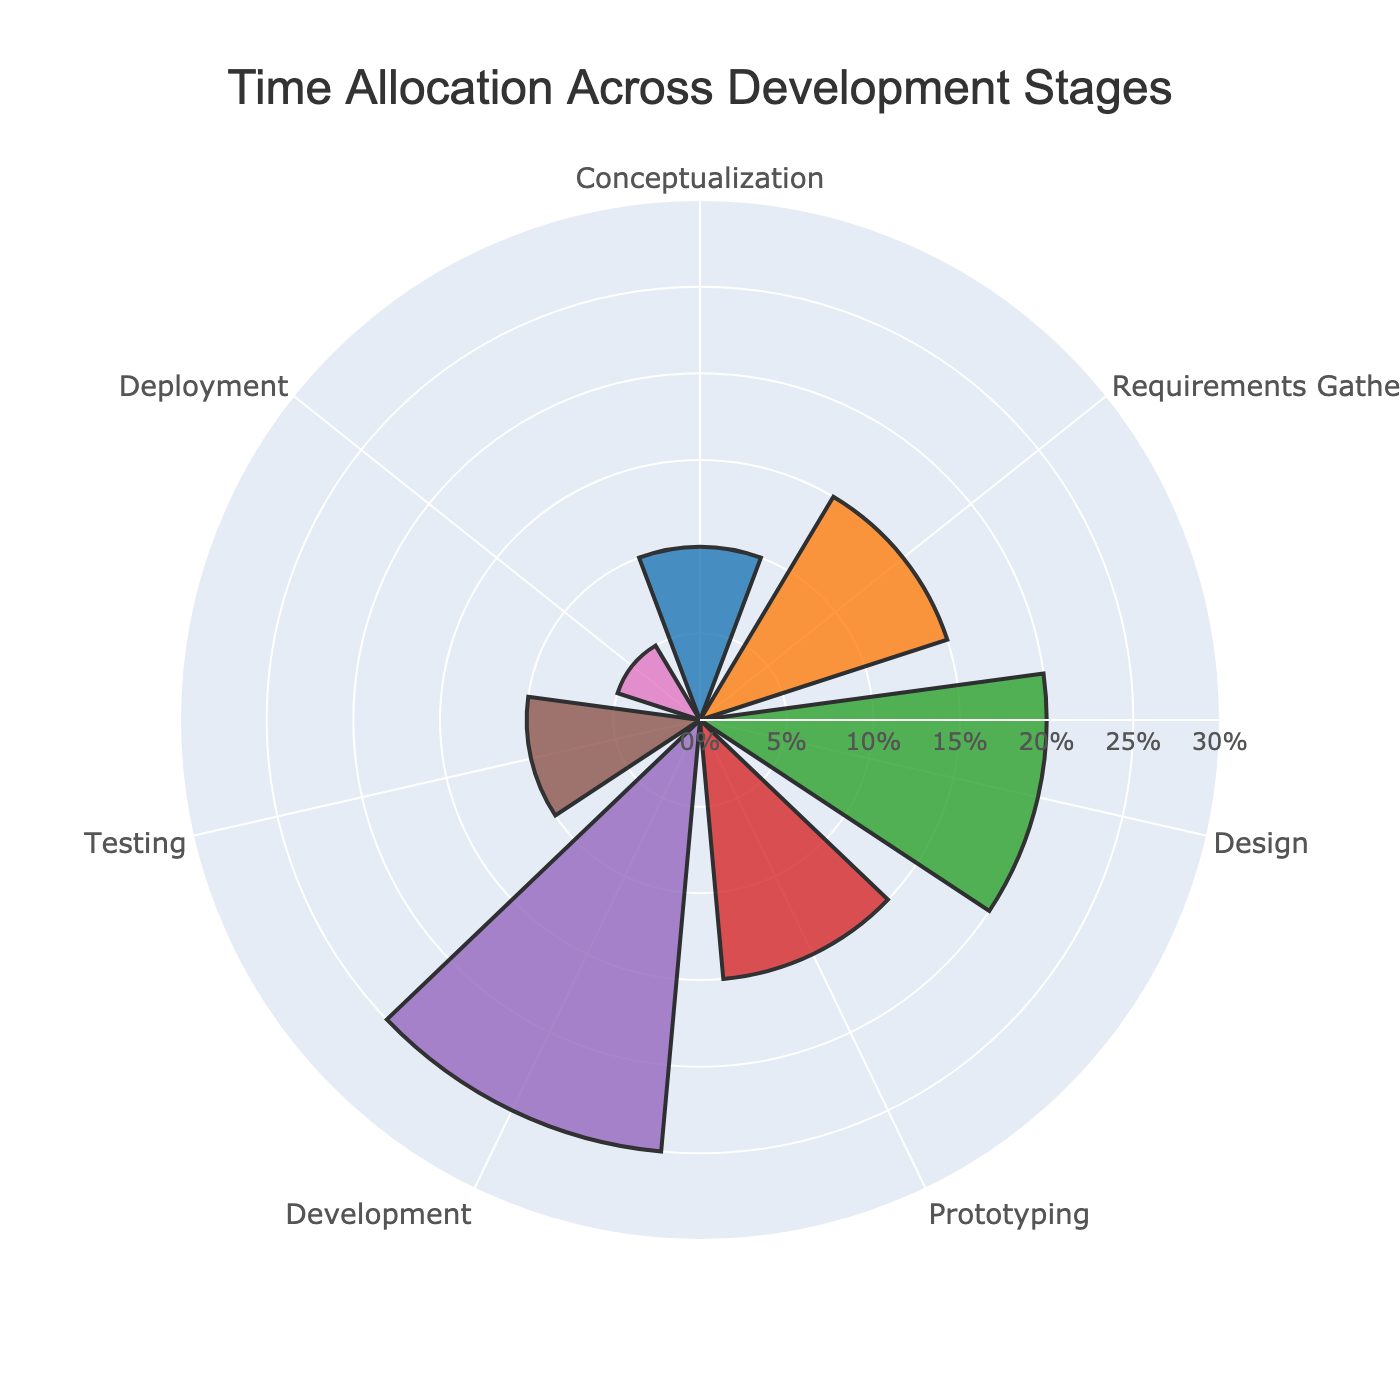What's the title of the figure? The title of the figure is prominently displayed at the top. It is provided to summarize what the figure is about.
Answer: Time Allocation Across Development Stages Which two stages have the same percentage of time allocation? By observing the bar lengths and values, we see that the 'Conceptualization' stage and the 'Testing' stage, both have a bar reaching the 10% mark.
Answer: Conceptualization and Testing What is the total time allocation for the 'Design' and 'Deployment' stages combined? The 'Design' stage has a time allocation of 20% and the 'Deployment' stage has 5%. Adding these two values together gives the total time allocation.
Answer: 25% Which stage has the highest time allocation? By identifying the longest bar, we can see that the 'Development' stage has the highest percentage of time allocation.
Answer: Development By how much does the time allocation for the 'Development' stage exceed the 'Prototyping' stage? The 'Development' stage has a time allocation of 25%, and the 'Prototyping' stage has 15%. Subtracting these, the difference is 10%.
Answer: 10% Are there any stages with less than 10% time allocation? We can see that 'Deployment' is the only stage with a 5% allocation, which is less than 10%.
Answer: Yes What is the average time allocation across all stages? Adding all time allocations: (10 + 15 + 20 + 15 + 25 + 10 + 5) and dividing by the number of stages (7) gives the average. The sum is 100, so the average is 100/7 ≈ 14.29.
Answer: 14.29% Which color represents the 'Prototyping' stage? By examining the chart, we see that the 'Prototyping' stage is represented by the green bar, positioned fourth clockwise.
Answer: Green 